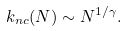Convert formula to latex. <formula><loc_0><loc_0><loc_500><loc_500>k _ { n c } ( N ) \sim N ^ { 1 / \gamma } .</formula> 